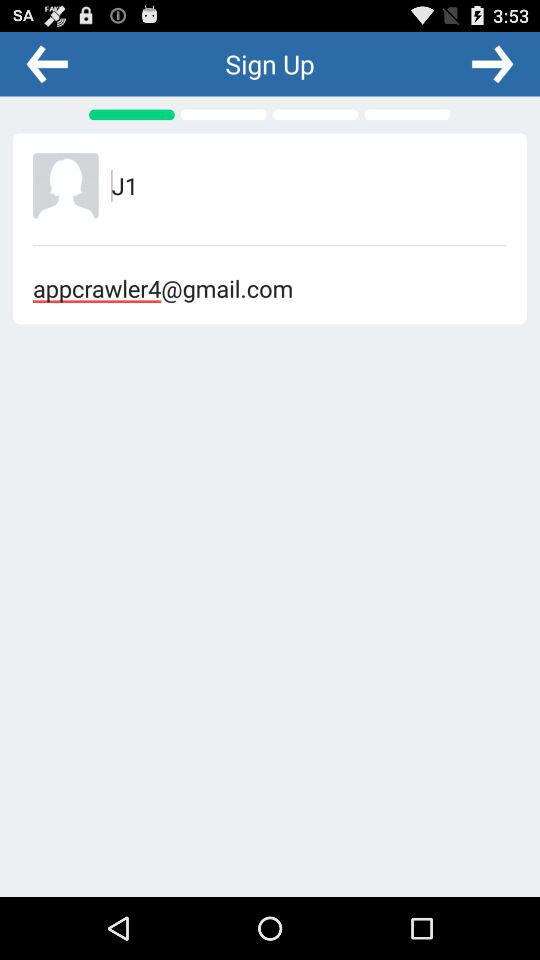What is the name of the user? The name of the user is J1. 